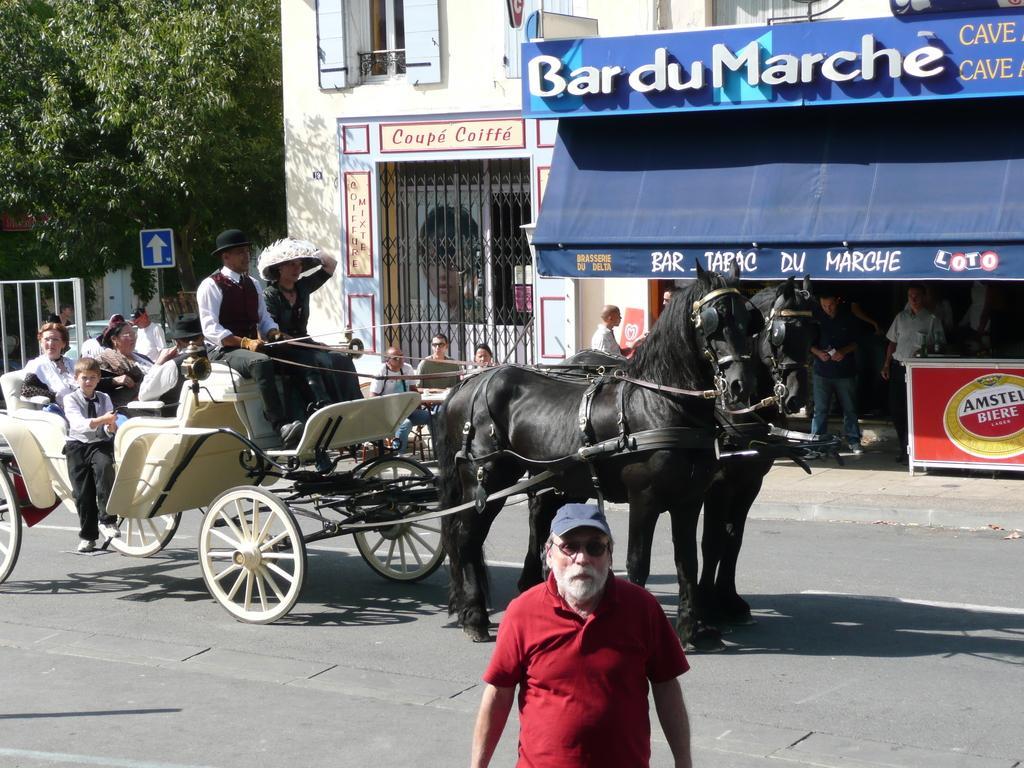Describe this image in one or two sentences. In the image in the center we can see two black color horses and we can see one wheel cart,which is attached with the horses. On the wheel cart,we can see few people were sitting. In the bottom of the image,we can see one person standing and wearing cap and red color t shirt. In the background we can see trees,banners,building,wall,window,sign board,few people were sitting,few people were standing etc. 